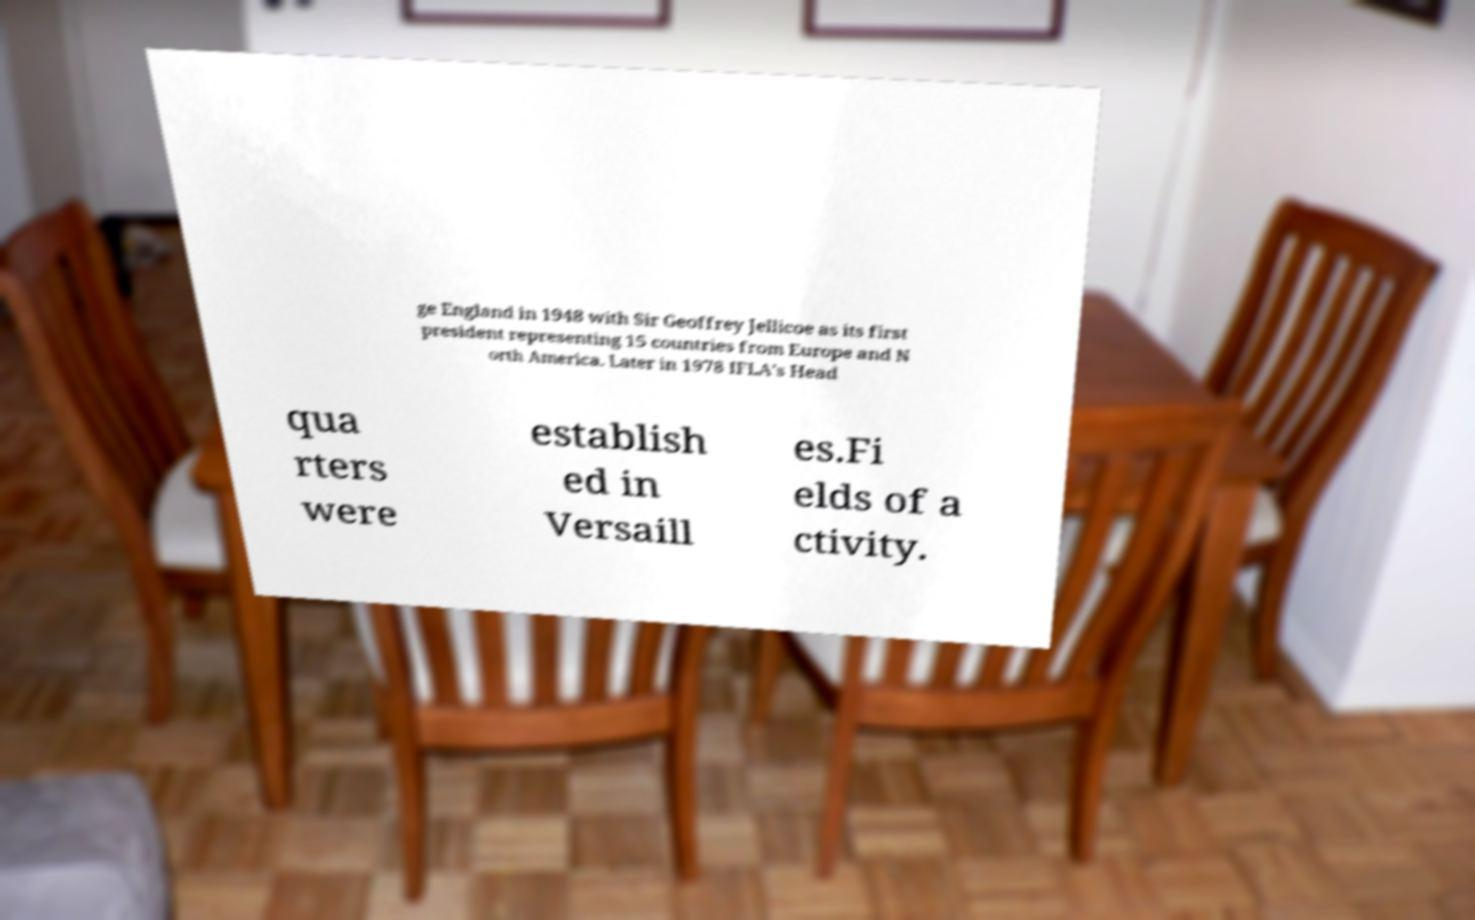What messages or text are displayed in this image? I need them in a readable, typed format. ge England in 1948 with Sir Geoffrey Jellicoe as its first president representing 15 countries from Europe and N orth America. Later in 1978 IFLA's Head qua rters were establish ed in Versaill es.Fi elds of a ctivity. 